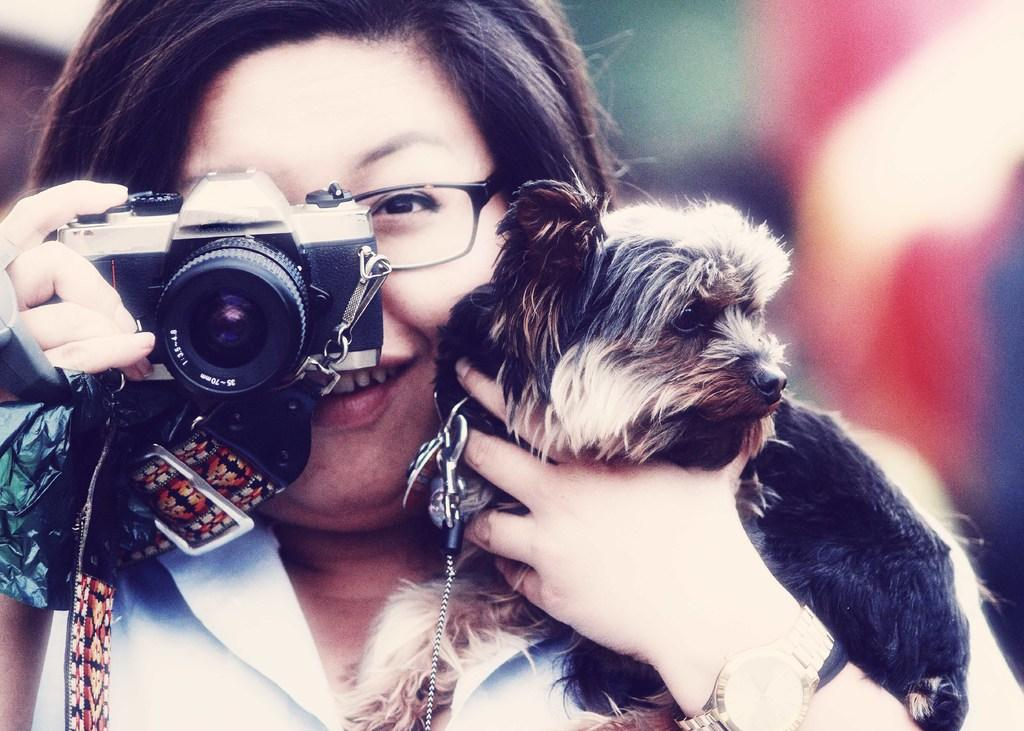What is the woman doing in the image? The woman is holding a dog with one hand and a camera with her other hand. What is the woman wearing on her face? The woman is wearing spectacles. How is the woman feeling in the image? The woman is smiling, which suggests she is happy or enjoying herself. What type of quiet example can be seen in the image? There is no reference to quietness or examples in the image; it features a woman holding a dog and a camera while wearing spectacles and smiling. 